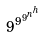Convert formula to latex. <formula><loc_0><loc_0><loc_500><loc_500>9 ^ { 9 ^ { 9 ^ { n ^ { h } } } }</formula> 